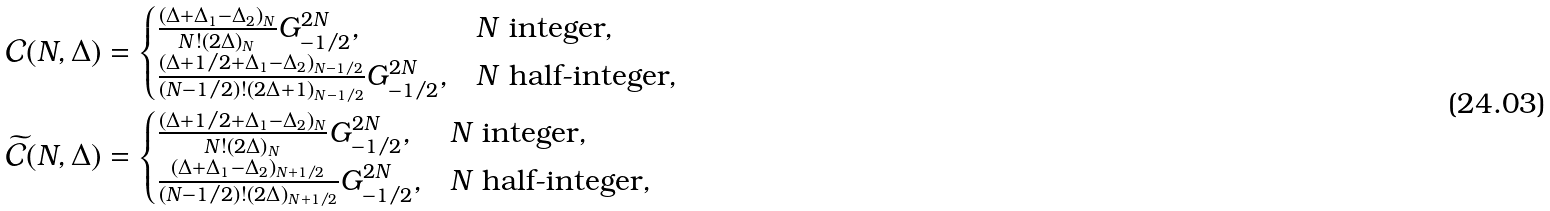<formula> <loc_0><loc_0><loc_500><loc_500>& \mathcal { C } ( N , \Delta ) = \begin{cases} \frac { ( \Delta + \Delta _ { 1 } - \Delta _ { 2 } ) _ { N } } { N ! ( 2 \Delta ) _ { N } } G _ { - 1 / 2 } ^ { 2 N } , & N \text { integer} , \\ \frac { ( \Delta + 1 / 2 + \Delta _ { 1 } - \Delta _ { 2 } ) _ { N - 1 / 2 } } { ( N - 1 / 2 ) ! ( 2 \Delta + 1 ) _ { N - 1 / 2 } } G _ { - 1 / 2 } ^ { 2 N } , & N \text { half-integer} , \end{cases} \\ & \widetilde { \mathcal { C } } ( N , \Delta ) = \begin{cases} \frac { ( \Delta + 1 / 2 + \Delta _ { 1 } - \Delta _ { 2 } ) _ { N } } { N ! ( 2 \Delta ) _ { N } } G _ { - 1 / 2 } ^ { 2 N } , & N \text { integer} , \\ \frac { ( \Delta + \Delta _ { 1 } - \Delta _ { 2 } ) _ { N + 1 / 2 } } { ( N - 1 / 2 ) ! ( 2 \Delta ) _ { N + 1 / 2 } } G _ { - 1 / 2 } ^ { 2 N } , & N \text { half-integer} , \end{cases}</formula> 